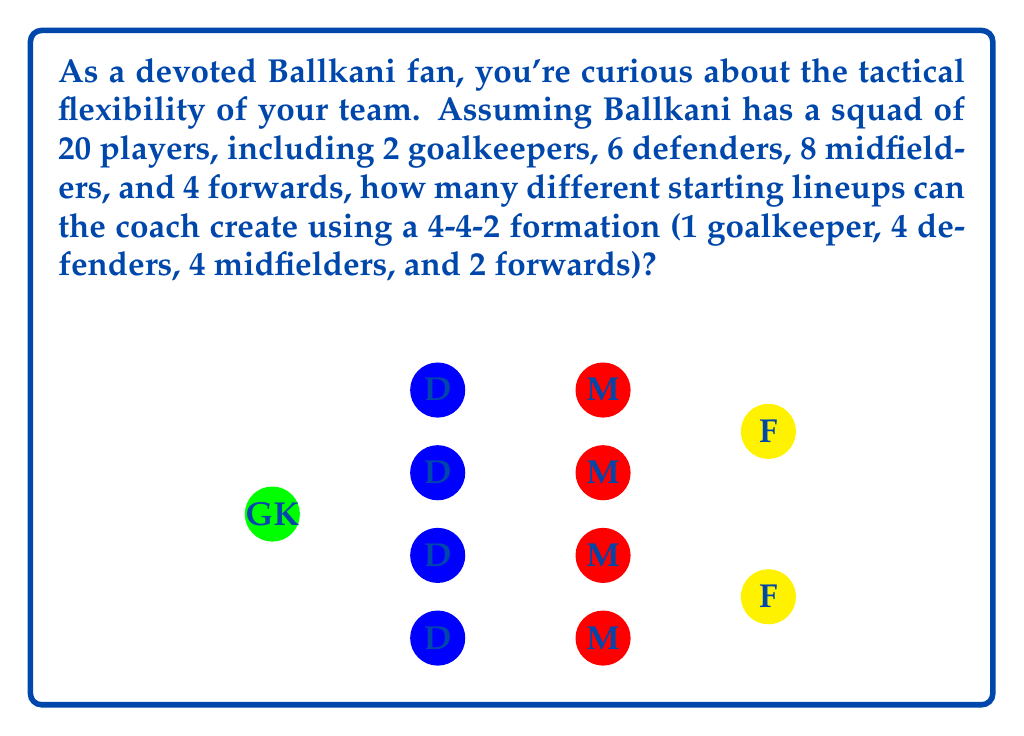Teach me how to tackle this problem. Let's break this down step-by-step:

1) First, we need to choose 1 goalkeeper out of 2:
   $${2 \choose 1} = 2$$

2) Next, we need to select 4 defenders out of 6:
   $${6 \choose 4} = 15$$

3) Then, we need to pick 4 midfielders out of 8:
   $${8 \choose 4} = 70$$

4) Finally, we need to choose 2 forwards out of 4:
   $${4 \choose 2} = 6$$

5) According to the multiplication principle, the total number of possible lineups is the product of these individual choices:

   $$2 \times 15 \times 70 \times 6 = 12,600$$

Therefore, the coach can create 12,600 different starting lineups using a 4-4-2 formation with the given squad.
Answer: 12,600 